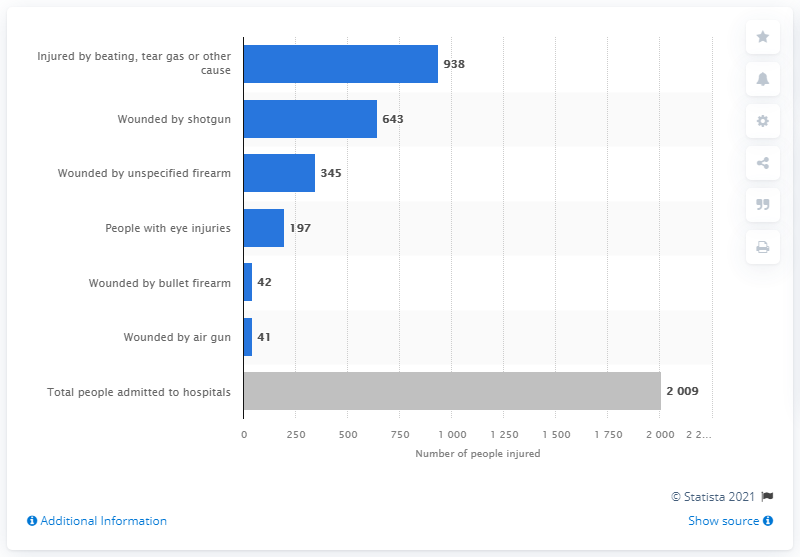Specify some key components in this picture. Sixty-four people were injured by shotguns. 